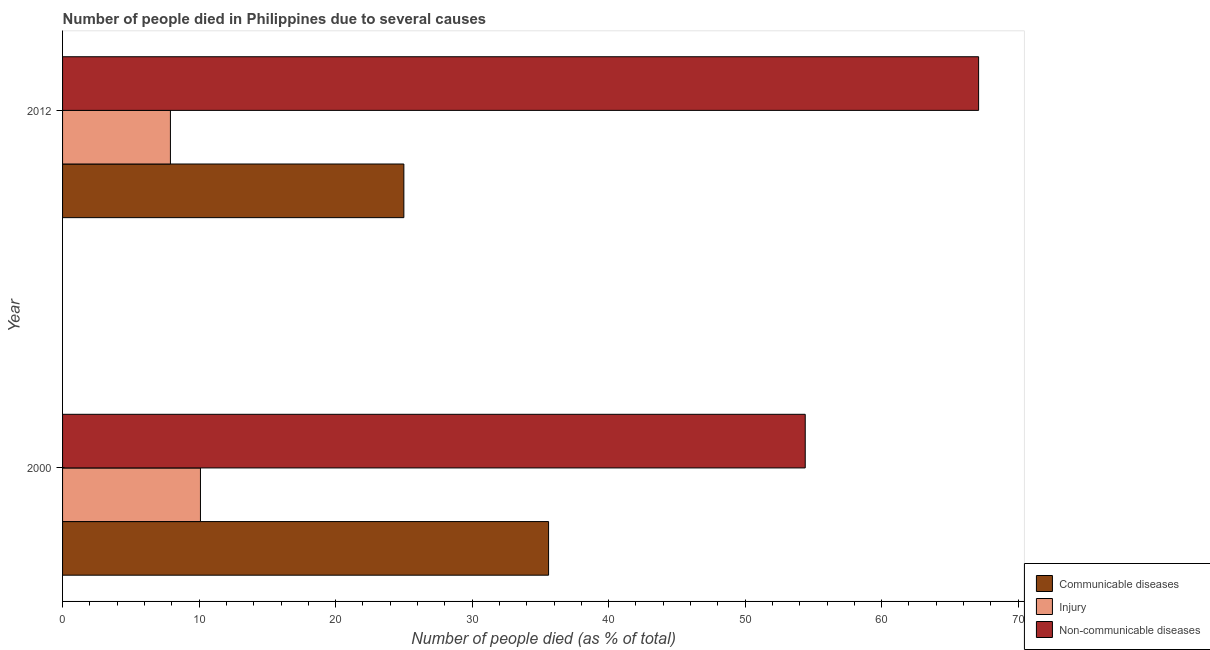How many groups of bars are there?
Offer a very short reply. 2. How many bars are there on the 1st tick from the top?
Offer a terse response. 3. How many bars are there on the 1st tick from the bottom?
Your answer should be very brief. 3. What is the label of the 1st group of bars from the top?
Keep it short and to the point. 2012. What is the number of people who dies of non-communicable diseases in 2000?
Provide a succinct answer. 54.4. Across all years, what is the minimum number of people who dies of non-communicable diseases?
Provide a succinct answer. 54.4. What is the total number of people who dies of non-communicable diseases in the graph?
Make the answer very short. 121.5. What is the difference between the number of people who died of communicable diseases in 2000 and that in 2012?
Give a very brief answer. 10.6. What is the difference between the number of people who died of injury in 2000 and the number of people who died of communicable diseases in 2012?
Your answer should be very brief. -14.9. What is the average number of people who died of injury per year?
Offer a very short reply. 9. In the year 2012, what is the difference between the number of people who died of injury and number of people who dies of non-communicable diseases?
Your answer should be very brief. -59.2. What is the ratio of the number of people who died of injury in 2000 to that in 2012?
Provide a succinct answer. 1.28. In how many years, is the number of people who died of injury greater than the average number of people who died of injury taken over all years?
Offer a very short reply. 1. What does the 1st bar from the top in 2000 represents?
Give a very brief answer. Non-communicable diseases. What does the 3rd bar from the bottom in 2000 represents?
Your answer should be compact. Non-communicable diseases. Are all the bars in the graph horizontal?
Make the answer very short. Yes. How many years are there in the graph?
Provide a succinct answer. 2. What is the difference between two consecutive major ticks on the X-axis?
Make the answer very short. 10. Are the values on the major ticks of X-axis written in scientific E-notation?
Provide a short and direct response. No. How many legend labels are there?
Your answer should be very brief. 3. What is the title of the graph?
Ensure brevity in your answer.  Number of people died in Philippines due to several causes. Does "Negligence towards kids" appear as one of the legend labels in the graph?
Provide a short and direct response. No. What is the label or title of the X-axis?
Give a very brief answer. Number of people died (as % of total). What is the label or title of the Y-axis?
Offer a very short reply. Year. What is the Number of people died (as % of total) in Communicable diseases in 2000?
Provide a short and direct response. 35.6. What is the Number of people died (as % of total) of Injury in 2000?
Keep it short and to the point. 10.1. What is the Number of people died (as % of total) of Non-communicable diseases in 2000?
Keep it short and to the point. 54.4. What is the Number of people died (as % of total) of Non-communicable diseases in 2012?
Offer a terse response. 67.1. Across all years, what is the maximum Number of people died (as % of total) in Communicable diseases?
Offer a very short reply. 35.6. Across all years, what is the maximum Number of people died (as % of total) in Injury?
Your answer should be compact. 10.1. Across all years, what is the maximum Number of people died (as % of total) in Non-communicable diseases?
Your answer should be compact. 67.1. Across all years, what is the minimum Number of people died (as % of total) in Non-communicable diseases?
Your answer should be compact. 54.4. What is the total Number of people died (as % of total) of Communicable diseases in the graph?
Make the answer very short. 60.6. What is the total Number of people died (as % of total) in Non-communicable diseases in the graph?
Ensure brevity in your answer.  121.5. What is the difference between the Number of people died (as % of total) in Communicable diseases in 2000 and that in 2012?
Provide a short and direct response. 10.6. What is the difference between the Number of people died (as % of total) of Injury in 2000 and that in 2012?
Keep it short and to the point. 2.2. What is the difference between the Number of people died (as % of total) in Communicable diseases in 2000 and the Number of people died (as % of total) in Injury in 2012?
Make the answer very short. 27.7. What is the difference between the Number of people died (as % of total) of Communicable diseases in 2000 and the Number of people died (as % of total) of Non-communicable diseases in 2012?
Make the answer very short. -31.5. What is the difference between the Number of people died (as % of total) of Injury in 2000 and the Number of people died (as % of total) of Non-communicable diseases in 2012?
Keep it short and to the point. -57. What is the average Number of people died (as % of total) of Communicable diseases per year?
Make the answer very short. 30.3. What is the average Number of people died (as % of total) of Injury per year?
Your answer should be very brief. 9. What is the average Number of people died (as % of total) in Non-communicable diseases per year?
Offer a terse response. 60.75. In the year 2000, what is the difference between the Number of people died (as % of total) in Communicable diseases and Number of people died (as % of total) in Non-communicable diseases?
Provide a succinct answer. -18.8. In the year 2000, what is the difference between the Number of people died (as % of total) in Injury and Number of people died (as % of total) in Non-communicable diseases?
Keep it short and to the point. -44.3. In the year 2012, what is the difference between the Number of people died (as % of total) in Communicable diseases and Number of people died (as % of total) in Injury?
Provide a short and direct response. 17.1. In the year 2012, what is the difference between the Number of people died (as % of total) of Communicable diseases and Number of people died (as % of total) of Non-communicable diseases?
Give a very brief answer. -42.1. In the year 2012, what is the difference between the Number of people died (as % of total) of Injury and Number of people died (as % of total) of Non-communicable diseases?
Provide a short and direct response. -59.2. What is the ratio of the Number of people died (as % of total) in Communicable diseases in 2000 to that in 2012?
Keep it short and to the point. 1.42. What is the ratio of the Number of people died (as % of total) in Injury in 2000 to that in 2012?
Keep it short and to the point. 1.28. What is the ratio of the Number of people died (as % of total) of Non-communicable diseases in 2000 to that in 2012?
Your answer should be compact. 0.81. What is the difference between the highest and the second highest Number of people died (as % of total) in Communicable diseases?
Make the answer very short. 10.6. What is the difference between the highest and the second highest Number of people died (as % of total) in Non-communicable diseases?
Ensure brevity in your answer.  12.7. What is the difference between the highest and the lowest Number of people died (as % of total) of Injury?
Give a very brief answer. 2.2. 